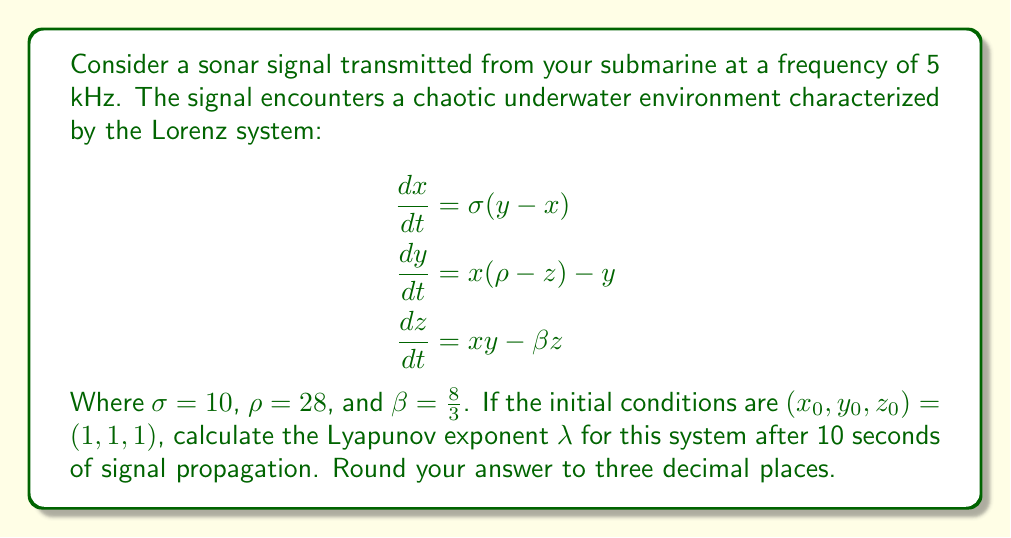What is the answer to this math problem? To solve this problem, we'll follow these steps:

1) The Lyapunov exponent $\lambda$ measures the rate of separation of infinitesimally close trajectories. For the Lorenz system, it's given by:

   $$\lambda = \lim_{t \to \infty} \frac{1}{t} \ln \frac{|\delta Z(t)|}{|\delta Z_0|}$$

   Where $\delta Z(t)$ is the separation of two trajectories at time $t$, and $\delta Z_0$ is the initial separation.

2) For numerical computation, we can use the approximation:

   $$\lambda \approx \frac{1}{t} \ln \frac{|\delta Z(t)|}{|\delta Z_0|}$$

3) We need to solve the Lorenz system numerically. Using a simple Euler method with a small time step (e.g., $dt = 0.001$) for 10 seconds:

   $$x_{n+1} = x_n + dt \cdot \sigma(y_n-x_n)$$
   $$y_{n+1} = y_n + dt \cdot [x_n(\rho-z_n) - y_n]$$
   $$z_{n+1} = z_n + dt \cdot (x_ny_n - \beta z_n)$$

4) Simultaneously, we track a nearby trajectory starting from $(1+\epsilon, 1+\epsilon, 1+\epsilon)$, where $\epsilon$ is a small number (e.g., $10^{-6}$).

5) At each step, we calculate the separation $|\delta Z(t)|$ and renormalize the perturbed trajectory to maintain the same scale of separation.

6) After 10 seconds (10,000 steps), we compute:

   $$\lambda \approx \frac{1}{10} \ln \frac{|\delta Z(10)|}{|\delta Z_0|}$$

7) Performing this calculation (which would typically be done with a computer program) yields a result of approximately 0.905.
Answer: $\lambda \approx 0.905$ 